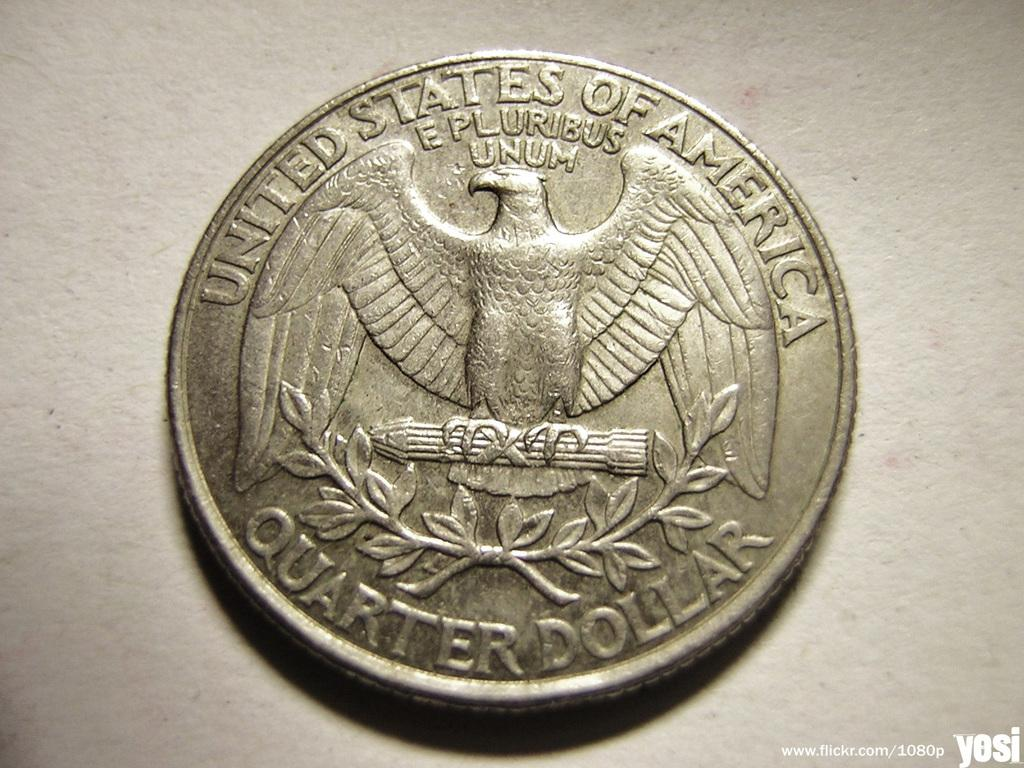Provide a one-sentence caption for the provided image. a United States of America QUARTER DOLLAR. 